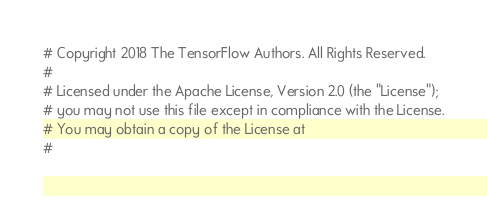Convert code to text. <code><loc_0><loc_0><loc_500><loc_500><_Python_># Copyright 2018 The TensorFlow Authors. All Rights Reserved.
#
# Licensed under the Apache License, Version 2.0 (the "License");
# you may not use this file except in compliance with the License.
# You may obtain a copy of the License at
#</code> 